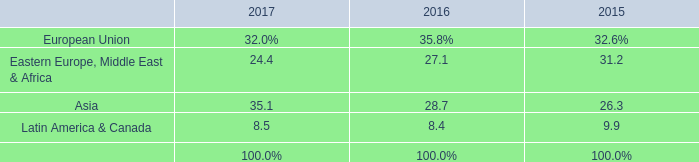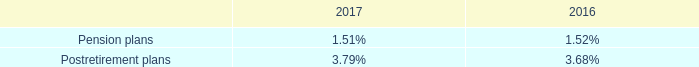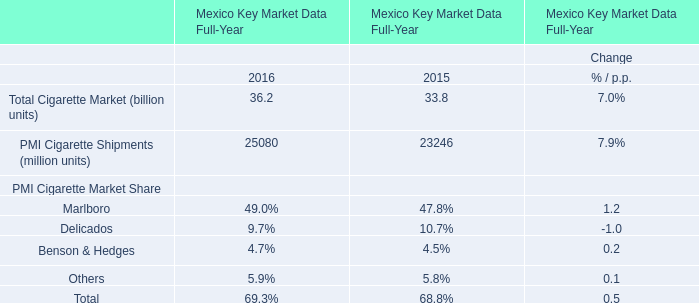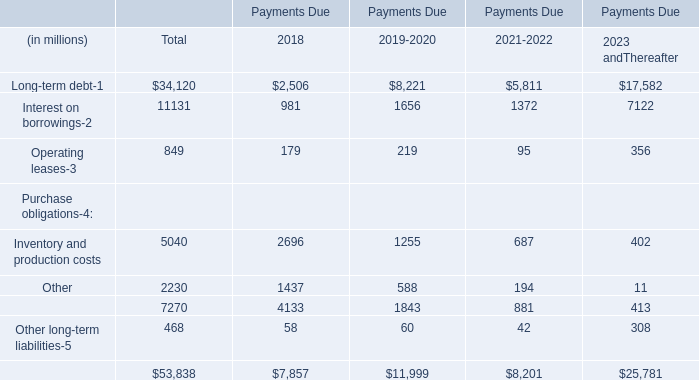In the section with lowest amount of Operating leases, what's the amount of Operating leases and Inventory and production costs (in million) 
Computations: (95 + 687)
Answer: 782.0. 